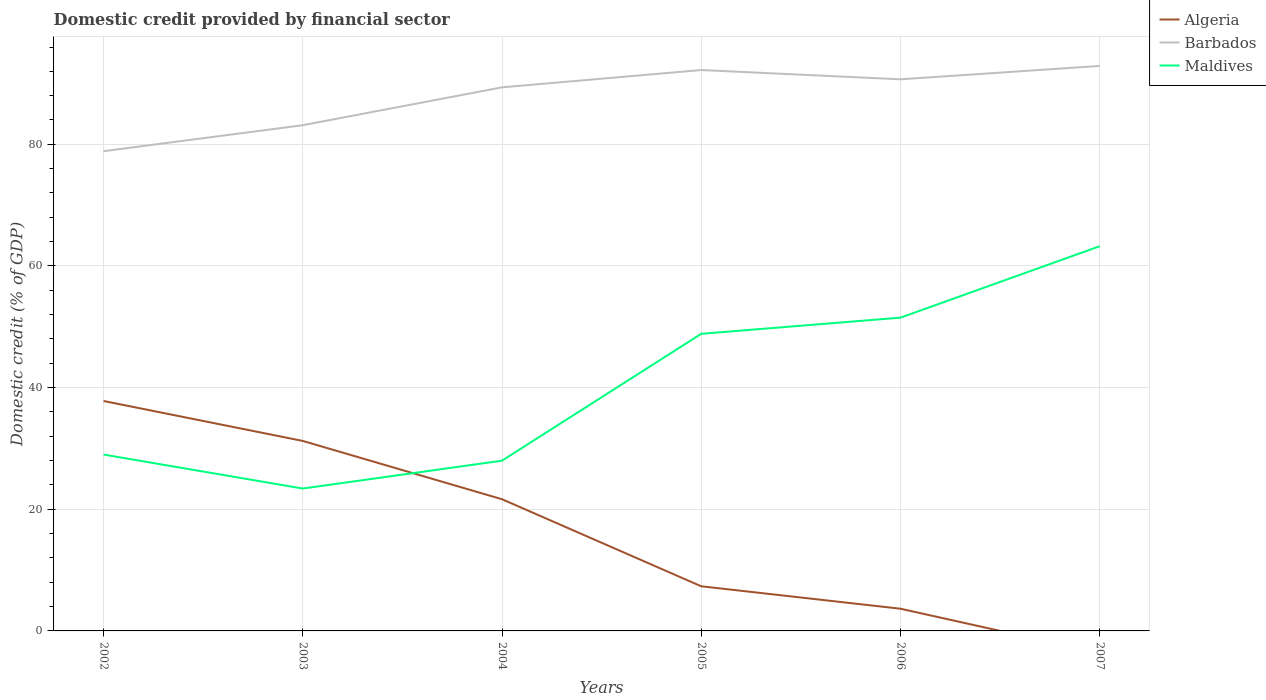How many different coloured lines are there?
Keep it short and to the point. 3. What is the total domestic credit in Maldives in the graph?
Keep it short and to the point. -2.66. What is the difference between the highest and the second highest domestic credit in Maldives?
Provide a short and direct response. 39.84. What is the difference between the highest and the lowest domestic credit in Barbados?
Provide a succinct answer. 4. How many lines are there?
Keep it short and to the point. 3. How many years are there in the graph?
Provide a succinct answer. 6. What is the difference between two consecutive major ticks on the Y-axis?
Offer a very short reply. 20. What is the title of the graph?
Make the answer very short. Domestic credit provided by financial sector. What is the label or title of the X-axis?
Your answer should be compact. Years. What is the label or title of the Y-axis?
Your response must be concise. Domestic credit (% of GDP). What is the Domestic credit (% of GDP) in Algeria in 2002?
Ensure brevity in your answer.  37.8. What is the Domestic credit (% of GDP) of Barbados in 2002?
Keep it short and to the point. 78.87. What is the Domestic credit (% of GDP) in Maldives in 2002?
Ensure brevity in your answer.  29. What is the Domestic credit (% of GDP) in Algeria in 2003?
Your answer should be compact. 31.24. What is the Domestic credit (% of GDP) in Barbados in 2003?
Offer a terse response. 83.14. What is the Domestic credit (% of GDP) of Maldives in 2003?
Keep it short and to the point. 23.41. What is the Domestic credit (% of GDP) of Algeria in 2004?
Give a very brief answer. 21.65. What is the Domestic credit (% of GDP) in Barbados in 2004?
Keep it short and to the point. 89.37. What is the Domestic credit (% of GDP) of Maldives in 2004?
Make the answer very short. 27.99. What is the Domestic credit (% of GDP) of Algeria in 2005?
Provide a succinct answer. 7.34. What is the Domestic credit (% of GDP) in Barbados in 2005?
Provide a short and direct response. 92.21. What is the Domestic credit (% of GDP) in Maldives in 2005?
Offer a very short reply. 48.85. What is the Domestic credit (% of GDP) in Algeria in 2006?
Provide a succinct answer. 3.65. What is the Domestic credit (% of GDP) of Barbados in 2006?
Offer a terse response. 90.69. What is the Domestic credit (% of GDP) of Maldives in 2006?
Your response must be concise. 51.5. What is the Domestic credit (% of GDP) of Algeria in 2007?
Give a very brief answer. 0. What is the Domestic credit (% of GDP) in Barbados in 2007?
Make the answer very short. 92.89. What is the Domestic credit (% of GDP) of Maldives in 2007?
Provide a short and direct response. 63.25. Across all years, what is the maximum Domestic credit (% of GDP) of Algeria?
Your answer should be compact. 37.8. Across all years, what is the maximum Domestic credit (% of GDP) in Barbados?
Your response must be concise. 92.89. Across all years, what is the maximum Domestic credit (% of GDP) in Maldives?
Your response must be concise. 63.25. Across all years, what is the minimum Domestic credit (% of GDP) in Barbados?
Your answer should be compact. 78.87. Across all years, what is the minimum Domestic credit (% of GDP) of Maldives?
Keep it short and to the point. 23.41. What is the total Domestic credit (% of GDP) in Algeria in the graph?
Keep it short and to the point. 101.68. What is the total Domestic credit (% of GDP) of Barbados in the graph?
Provide a succinct answer. 527.17. What is the total Domestic credit (% of GDP) of Maldives in the graph?
Offer a terse response. 244. What is the difference between the Domestic credit (% of GDP) of Algeria in 2002 and that in 2003?
Your answer should be very brief. 6.57. What is the difference between the Domestic credit (% of GDP) in Barbados in 2002 and that in 2003?
Provide a succinct answer. -4.27. What is the difference between the Domestic credit (% of GDP) in Maldives in 2002 and that in 2003?
Ensure brevity in your answer.  5.59. What is the difference between the Domestic credit (% of GDP) of Algeria in 2002 and that in 2004?
Make the answer very short. 16.15. What is the difference between the Domestic credit (% of GDP) of Barbados in 2002 and that in 2004?
Provide a short and direct response. -10.5. What is the difference between the Domestic credit (% of GDP) of Maldives in 2002 and that in 2004?
Offer a terse response. 1.01. What is the difference between the Domestic credit (% of GDP) in Algeria in 2002 and that in 2005?
Keep it short and to the point. 30.46. What is the difference between the Domestic credit (% of GDP) in Barbados in 2002 and that in 2005?
Make the answer very short. -13.34. What is the difference between the Domestic credit (% of GDP) in Maldives in 2002 and that in 2005?
Provide a succinct answer. -19.85. What is the difference between the Domestic credit (% of GDP) of Algeria in 2002 and that in 2006?
Your answer should be compact. 34.15. What is the difference between the Domestic credit (% of GDP) in Barbados in 2002 and that in 2006?
Provide a short and direct response. -11.82. What is the difference between the Domestic credit (% of GDP) of Maldives in 2002 and that in 2006?
Your response must be concise. -22.51. What is the difference between the Domestic credit (% of GDP) of Barbados in 2002 and that in 2007?
Offer a terse response. -14.02. What is the difference between the Domestic credit (% of GDP) of Maldives in 2002 and that in 2007?
Your response must be concise. -34.25. What is the difference between the Domestic credit (% of GDP) in Algeria in 2003 and that in 2004?
Give a very brief answer. 9.58. What is the difference between the Domestic credit (% of GDP) in Barbados in 2003 and that in 2004?
Keep it short and to the point. -6.23. What is the difference between the Domestic credit (% of GDP) of Maldives in 2003 and that in 2004?
Give a very brief answer. -4.58. What is the difference between the Domestic credit (% of GDP) of Algeria in 2003 and that in 2005?
Offer a very short reply. 23.9. What is the difference between the Domestic credit (% of GDP) in Barbados in 2003 and that in 2005?
Offer a terse response. -9.07. What is the difference between the Domestic credit (% of GDP) in Maldives in 2003 and that in 2005?
Provide a succinct answer. -25.44. What is the difference between the Domestic credit (% of GDP) in Algeria in 2003 and that in 2006?
Offer a very short reply. 27.59. What is the difference between the Domestic credit (% of GDP) in Barbados in 2003 and that in 2006?
Give a very brief answer. -7.55. What is the difference between the Domestic credit (% of GDP) of Maldives in 2003 and that in 2006?
Ensure brevity in your answer.  -28.1. What is the difference between the Domestic credit (% of GDP) of Barbados in 2003 and that in 2007?
Give a very brief answer. -9.75. What is the difference between the Domestic credit (% of GDP) in Maldives in 2003 and that in 2007?
Provide a short and direct response. -39.84. What is the difference between the Domestic credit (% of GDP) of Algeria in 2004 and that in 2005?
Make the answer very short. 14.31. What is the difference between the Domestic credit (% of GDP) of Barbados in 2004 and that in 2005?
Offer a very short reply. -2.84. What is the difference between the Domestic credit (% of GDP) in Maldives in 2004 and that in 2005?
Offer a terse response. -20.86. What is the difference between the Domestic credit (% of GDP) in Algeria in 2004 and that in 2006?
Offer a terse response. 18. What is the difference between the Domestic credit (% of GDP) in Barbados in 2004 and that in 2006?
Provide a short and direct response. -1.32. What is the difference between the Domestic credit (% of GDP) of Maldives in 2004 and that in 2006?
Keep it short and to the point. -23.52. What is the difference between the Domestic credit (% of GDP) of Barbados in 2004 and that in 2007?
Offer a terse response. -3.52. What is the difference between the Domestic credit (% of GDP) of Maldives in 2004 and that in 2007?
Provide a succinct answer. -35.26. What is the difference between the Domestic credit (% of GDP) in Algeria in 2005 and that in 2006?
Give a very brief answer. 3.69. What is the difference between the Domestic credit (% of GDP) of Barbados in 2005 and that in 2006?
Give a very brief answer. 1.52. What is the difference between the Domestic credit (% of GDP) in Maldives in 2005 and that in 2006?
Your response must be concise. -2.66. What is the difference between the Domestic credit (% of GDP) of Barbados in 2005 and that in 2007?
Offer a terse response. -0.68. What is the difference between the Domestic credit (% of GDP) in Maldives in 2005 and that in 2007?
Ensure brevity in your answer.  -14.4. What is the difference between the Domestic credit (% of GDP) in Barbados in 2006 and that in 2007?
Keep it short and to the point. -2.2. What is the difference between the Domestic credit (% of GDP) of Maldives in 2006 and that in 2007?
Offer a terse response. -11.75. What is the difference between the Domestic credit (% of GDP) in Algeria in 2002 and the Domestic credit (% of GDP) in Barbados in 2003?
Give a very brief answer. -45.34. What is the difference between the Domestic credit (% of GDP) in Algeria in 2002 and the Domestic credit (% of GDP) in Maldives in 2003?
Your answer should be very brief. 14.39. What is the difference between the Domestic credit (% of GDP) in Barbados in 2002 and the Domestic credit (% of GDP) in Maldives in 2003?
Your answer should be very brief. 55.46. What is the difference between the Domestic credit (% of GDP) of Algeria in 2002 and the Domestic credit (% of GDP) of Barbados in 2004?
Offer a terse response. -51.57. What is the difference between the Domestic credit (% of GDP) in Algeria in 2002 and the Domestic credit (% of GDP) in Maldives in 2004?
Ensure brevity in your answer.  9.81. What is the difference between the Domestic credit (% of GDP) of Barbados in 2002 and the Domestic credit (% of GDP) of Maldives in 2004?
Ensure brevity in your answer.  50.88. What is the difference between the Domestic credit (% of GDP) in Algeria in 2002 and the Domestic credit (% of GDP) in Barbados in 2005?
Offer a very short reply. -54.41. What is the difference between the Domestic credit (% of GDP) of Algeria in 2002 and the Domestic credit (% of GDP) of Maldives in 2005?
Give a very brief answer. -11.05. What is the difference between the Domestic credit (% of GDP) of Barbados in 2002 and the Domestic credit (% of GDP) of Maldives in 2005?
Your answer should be compact. 30.02. What is the difference between the Domestic credit (% of GDP) of Algeria in 2002 and the Domestic credit (% of GDP) of Barbados in 2006?
Offer a very short reply. -52.89. What is the difference between the Domestic credit (% of GDP) of Algeria in 2002 and the Domestic credit (% of GDP) of Maldives in 2006?
Keep it short and to the point. -13.7. What is the difference between the Domestic credit (% of GDP) of Barbados in 2002 and the Domestic credit (% of GDP) of Maldives in 2006?
Offer a terse response. 27.37. What is the difference between the Domestic credit (% of GDP) of Algeria in 2002 and the Domestic credit (% of GDP) of Barbados in 2007?
Offer a very short reply. -55.09. What is the difference between the Domestic credit (% of GDP) of Algeria in 2002 and the Domestic credit (% of GDP) of Maldives in 2007?
Make the answer very short. -25.45. What is the difference between the Domestic credit (% of GDP) of Barbados in 2002 and the Domestic credit (% of GDP) of Maldives in 2007?
Give a very brief answer. 15.62. What is the difference between the Domestic credit (% of GDP) in Algeria in 2003 and the Domestic credit (% of GDP) in Barbados in 2004?
Your response must be concise. -58.13. What is the difference between the Domestic credit (% of GDP) of Algeria in 2003 and the Domestic credit (% of GDP) of Maldives in 2004?
Offer a very short reply. 3.25. What is the difference between the Domestic credit (% of GDP) in Barbados in 2003 and the Domestic credit (% of GDP) in Maldives in 2004?
Your answer should be very brief. 55.15. What is the difference between the Domestic credit (% of GDP) of Algeria in 2003 and the Domestic credit (% of GDP) of Barbados in 2005?
Your response must be concise. -60.98. What is the difference between the Domestic credit (% of GDP) of Algeria in 2003 and the Domestic credit (% of GDP) of Maldives in 2005?
Give a very brief answer. -17.61. What is the difference between the Domestic credit (% of GDP) of Barbados in 2003 and the Domestic credit (% of GDP) of Maldives in 2005?
Give a very brief answer. 34.29. What is the difference between the Domestic credit (% of GDP) of Algeria in 2003 and the Domestic credit (% of GDP) of Barbados in 2006?
Keep it short and to the point. -59.45. What is the difference between the Domestic credit (% of GDP) of Algeria in 2003 and the Domestic credit (% of GDP) of Maldives in 2006?
Ensure brevity in your answer.  -20.27. What is the difference between the Domestic credit (% of GDP) of Barbados in 2003 and the Domestic credit (% of GDP) of Maldives in 2006?
Provide a short and direct response. 31.64. What is the difference between the Domestic credit (% of GDP) of Algeria in 2003 and the Domestic credit (% of GDP) of Barbados in 2007?
Ensure brevity in your answer.  -61.65. What is the difference between the Domestic credit (% of GDP) of Algeria in 2003 and the Domestic credit (% of GDP) of Maldives in 2007?
Offer a very short reply. -32.01. What is the difference between the Domestic credit (% of GDP) of Barbados in 2003 and the Domestic credit (% of GDP) of Maldives in 2007?
Your response must be concise. 19.89. What is the difference between the Domestic credit (% of GDP) of Algeria in 2004 and the Domestic credit (% of GDP) of Barbados in 2005?
Provide a short and direct response. -70.56. What is the difference between the Domestic credit (% of GDP) of Algeria in 2004 and the Domestic credit (% of GDP) of Maldives in 2005?
Make the answer very short. -27.2. What is the difference between the Domestic credit (% of GDP) of Barbados in 2004 and the Domestic credit (% of GDP) of Maldives in 2005?
Your answer should be very brief. 40.52. What is the difference between the Domestic credit (% of GDP) of Algeria in 2004 and the Domestic credit (% of GDP) of Barbados in 2006?
Your response must be concise. -69.04. What is the difference between the Domestic credit (% of GDP) of Algeria in 2004 and the Domestic credit (% of GDP) of Maldives in 2006?
Keep it short and to the point. -29.85. What is the difference between the Domestic credit (% of GDP) in Barbados in 2004 and the Domestic credit (% of GDP) in Maldives in 2006?
Keep it short and to the point. 37.86. What is the difference between the Domestic credit (% of GDP) of Algeria in 2004 and the Domestic credit (% of GDP) of Barbados in 2007?
Make the answer very short. -71.24. What is the difference between the Domestic credit (% of GDP) in Algeria in 2004 and the Domestic credit (% of GDP) in Maldives in 2007?
Offer a terse response. -41.6. What is the difference between the Domestic credit (% of GDP) of Barbados in 2004 and the Domestic credit (% of GDP) of Maldives in 2007?
Provide a short and direct response. 26.12. What is the difference between the Domestic credit (% of GDP) in Algeria in 2005 and the Domestic credit (% of GDP) in Barbados in 2006?
Make the answer very short. -83.35. What is the difference between the Domestic credit (% of GDP) of Algeria in 2005 and the Domestic credit (% of GDP) of Maldives in 2006?
Make the answer very short. -44.17. What is the difference between the Domestic credit (% of GDP) in Barbados in 2005 and the Domestic credit (% of GDP) in Maldives in 2006?
Provide a succinct answer. 40.71. What is the difference between the Domestic credit (% of GDP) of Algeria in 2005 and the Domestic credit (% of GDP) of Barbados in 2007?
Keep it short and to the point. -85.55. What is the difference between the Domestic credit (% of GDP) of Algeria in 2005 and the Domestic credit (% of GDP) of Maldives in 2007?
Your answer should be very brief. -55.91. What is the difference between the Domestic credit (% of GDP) of Barbados in 2005 and the Domestic credit (% of GDP) of Maldives in 2007?
Provide a succinct answer. 28.96. What is the difference between the Domestic credit (% of GDP) of Algeria in 2006 and the Domestic credit (% of GDP) of Barbados in 2007?
Give a very brief answer. -89.24. What is the difference between the Domestic credit (% of GDP) in Algeria in 2006 and the Domestic credit (% of GDP) in Maldives in 2007?
Offer a very short reply. -59.6. What is the difference between the Domestic credit (% of GDP) of Barbados in 2006 and the Domestic credit (% of GDP) of Maldives in 2007?
Keep it short and to the point. 27.44. What is the average Domestic credit (% of GDP) of Algeria per year?
Ensure brevity in your answer.  16.95. What is the average Domestic credit (% of GDP) in Barbados per year?
Give a very brief answer. 87.86. What is the average Domestic credit (% of GDP) of Maldives per year?
Provide a short and direct response. 40.67. In the year 2002, what is the difference between the Domestic credit (% of GDP) of Algeria and Domestic credit (% of GDP) of Barbados?
Offer a very short reply. -41.07. In the year 2002, what is the difference between the Domestic credit (% of GDP) of Algeria and Domestic credit (% of GDP) of Maldives?
Ensure brevity in your answer.  8.81. In the year 2002, what is the difference between the Domestic credit (% of GDP) in Barbados and Domestic credit (% of GDP) in Maldives?
Offer a terse response. 49.87. In the year 2003, what is the difference between the Domestic credit (% of GDP) of Algeria and Domestic credit (% of GDP) of Barbados?
Give a very brief answer. -51.91. In the year 2003, what is the difference between the Domestic credit (% of GDP) in Algeria and Domestic credit (% of GDP) in Maldives?
Provide a succinct answer. 7.83. In the year 2003, what is the difference between the Domestic credit (% of GDP) of Barbados and Domestic credit (% of GDP) of Maldives?
Your answer should be compact. 59.73. In the year 2004, what is the difference between the Domestic credit (% of GDP) in Algeria and Domestic credit (% of GDP) in Barbados?
Give a very brief answer. -67.72. In the year 2004, what is the difference between the Domestic credit (% of GDP) of Algeria and Domestic credit (% of GDP) of Maldives?
Offer a very short reply. -6.34. In the year 2004, what is the difference between the Domestic credit (% of GDP) of Barbados and Domestic credit (% of GDP) of Maldives?
Your answer should be very brief. 61.38. In the year 2005, what is the difference between the Domestic credit (% of GDP) of Algeria and Domestic credit (% of GDP) of Barbados?
Keep it short and to the point. -84.87. In the year 2005, what is the difference between the Domestic credit (% of GDP) in Algeria and Domestic credit (% of GDP) in Maldives?
Keep it short and to the point. -41.51. In the year 2005, what is the difference between the Domestic credit (% of GDP) in Barbados and Domestic credit (% of GDP) in Maldives?
Offer a very short reply. 43.36. In the year 2006, what is the difference between the Domestic credit (% of GDP) in Algeria and Domestic credit (% of GDP) in Barbados?
Offer a terse response. -87.04. In the year 2006, what is the difference between the Domestic credit (% of GDP) in Algeria and Domestic credit (% of GDP) in Maldives?
Ensure brevity in your answer.  -47.86. In the year 2006, what is the difference between the Domestic credit (% of GDP) of Barbados and Domestic credit (% of GDP) of Maldives?
Keep it short and to the point. 39.18. In the year 2007, what is the difference between the Domestic credit (% of GDP) of Barbados and Domestic credit (% of GDP) of Maldives?
Make the answer very short. 29.64. What is the ratio of the Domestic credit (% of GDP) in Algeria in 2002 to that in 2003?
Keep it short and to the point. 1.21. What is the ratio of the Domestic credit (% of GDP) in Barbados in 2002 to that in 2003?
Your answer should be very brief. 0.95. What is the ratio of the Domestic credit (% of GDP) of Maldives in 2002 to that in 2003?
Provide a succinct answer. 1.24. What is the ratio of the Domestic credit (% of GDP) in Algeria in 2002 to that in 2004?
Offer a very short reply. 1.75. What is the ratio of the Domestic credit (% of GDP) in Barbados in 2002 to that in 2004?
Your answer should be very brief. 0.88. What is the ratio of the Domestic credit (% of GDP) of Maldives in 2002 to that in 2004?
Your response must be concise. 1.04. What is the ratio of the Domestic credit (% of GDP) of Algeria in 2002 to that in 2005?
Keep it short and to the point. 5.15. What is the ratio of the Domestic credit (% of GDP) in Barbados in 2002 to that in 2005?
Your answer should be compact. 0.86. What is the ratio of the Domestic credit (% of GDP) of Maldives in 2002 to that in 2005?
Provide a succinct answer. 0.59. What is the ratio of the Domestic credit (% of GDP) in Algeria in 2002 to that in 2006?
Keep it short and to the point. 10.36. What is the ratio of the Domestic credit (% of GDP) of Barbados in 2002 to that in 2006?
Offer a very short reply. 0.87. What is the ratio of the Domestic credit (% of GDP) of Maldives in 2002 to that in 2006?
Provide a short and direct response. 0.56. What is the ratio of the Domestic credit (% of GDP) in Barbados in 2002 to that in 2007?
Your response must be concise. 0.85. What is the ratio of the Domestic credit (% of GDP) in Maldives in 2002 to that in 2007?
Give a very brief answer. 0.46. What is the ratio of the Domestic credit (% of GDP) of Algeria in 2003 to that in 2004?
Provide a succinct answer. 1.44. What is the ratio of the Domestic credit (% of GDP) of Barbados in 2003 to that in 2004?
Your answer should be compact. 0.93. What is the ratio of the Domestic credit (% of GDP) in Maldives in 2003 to that in 2004?
Your answer should be compact. 0.84. What is the ratio of the Domestic credit (% of GDP) of Algeria in 2003 to that in 2005?
Make the answer very short. 4.26. What is the ratio of the Domestic credit (% of GDP) in Barbados in 2003 to that in 2005?
Give a very brief answer. 0.9. What is the ratio of the Domestic credit (% of GDP) in Maldives in 2003 to that in 2005?
Provide a succinct answer. 0.48. What is the ratio of the Domestic credit (% of GDP) of Algeria in 2003 to that in 2006?
Your answer should be compact. 8.56. What is the ratio of the Domestic credit (% of GDP) of Barbados in 2003 to that in 2006?
Your response must be concise. 0.92. What is the ratio of the Domestic credit (% of GDP) in Maldives in 2003 to that in 2006?
Your answer should be compact. 0.45. What is the ratio of the Domestic credit (% of GDP) in Barbados in 2003 to that in 2007?
Offer a terse response. 0.9. What is the ratio of the Domestic credit (% of GDP) of Maldives in 2003 to that in 2007?
Provide a short and direct response. 0.37. What is the ratio of the Domestic credit (% of GDP) in Algeria in 2004 to that in 2005?
Offer a terse response. 2.95. What is the ratio of the Domestic credit (% of GDP) of Barbados in 2004 to that in 2005?
Your response must be concise. 0.97. What is the ratio of the Domestic credit (% of GDP) of Maldives in 2004 to that in 2005?
Keep it short and to the point. 0.57. What is the ratio of the Domestic credit (% of GDP) in Algeria in 2004 to that in 2006?
Give a very brief answer. 5.93. What is the ratio of the Domestic credit (% of GDP) in Barbados in 2004 to that in 2006?
Provide a short and direct response. 0.99. What is the ratio of the Domestic credit (% of GDP) in Maldives in 2004 to that in 2006?
Ensure brevity in your answer.  0.54. What is the ratio of the Domestic credit (% of GDP) of Barbados in 2004 to that in 2007?
Give a very brief answer. 0.96. What is the ratio of the Domestic credit (% of GDP) in Maldives in 2004 to that in 2007?
Offer a terse response. 0.44. What is the ratio of the Domestic credit (% of GDP) in Algeria in 2005 to that in 2006?
Offer a very short reply. 2.01. What is the ratio of the Domestic credit (% of GDP) of Barbados in 2005 to that in 2006?
Provide a succinct answer. 1.02. What is the ratio of the Domestic credit (% of GDP) in Maldives in 2005 to that in 2006?
Offer a very short reply. 0.95. What is the ratio of the Domestic credit (% of GDP) in Barbados in 2005 to that in 2007?
Offer a very short reply. 0.99. What is the ratio of the Domestic credit (% of GDP) in Maldives in 2005 to that in 2007?
Your response must be concise. 0.77. What is the ratio of the Domestic credit (% of GDP) of Barbados in 2006 to that in 2007?
Offer a very short reply. 0.98. What is the ratio of the Domestic credit (% of GDP) in Maldives in 2006 to that in 2007?
Give a very brief answer. 0.81. What is the difference between the highest and the second highest Domestic credit (% of GDP) in Algeria?
Provide a succinct answer. 6.57. What is the difference between the highest and the second highest Domestic credit (% of GDP) in Barbados?
Your response must be concise. 0.68. What is the difference between the highest and the second highest Domestic credit (% of GDP) of Maldives?
Keep it short and to the point. 11.75. What is the difference between the highest and the lowest Domestic credit (% of GDP) of Algeria?
Make the answer very short. 37.8. What is the difference between the highest and the lowest Domestic credit (% of GDP) in Barbados?
Provide a short and direct response. 14.02. What is the difference between the highest and the lowest Domestic credit (% of GDP) in Maldives?
Offer a terse response. 39.84. 